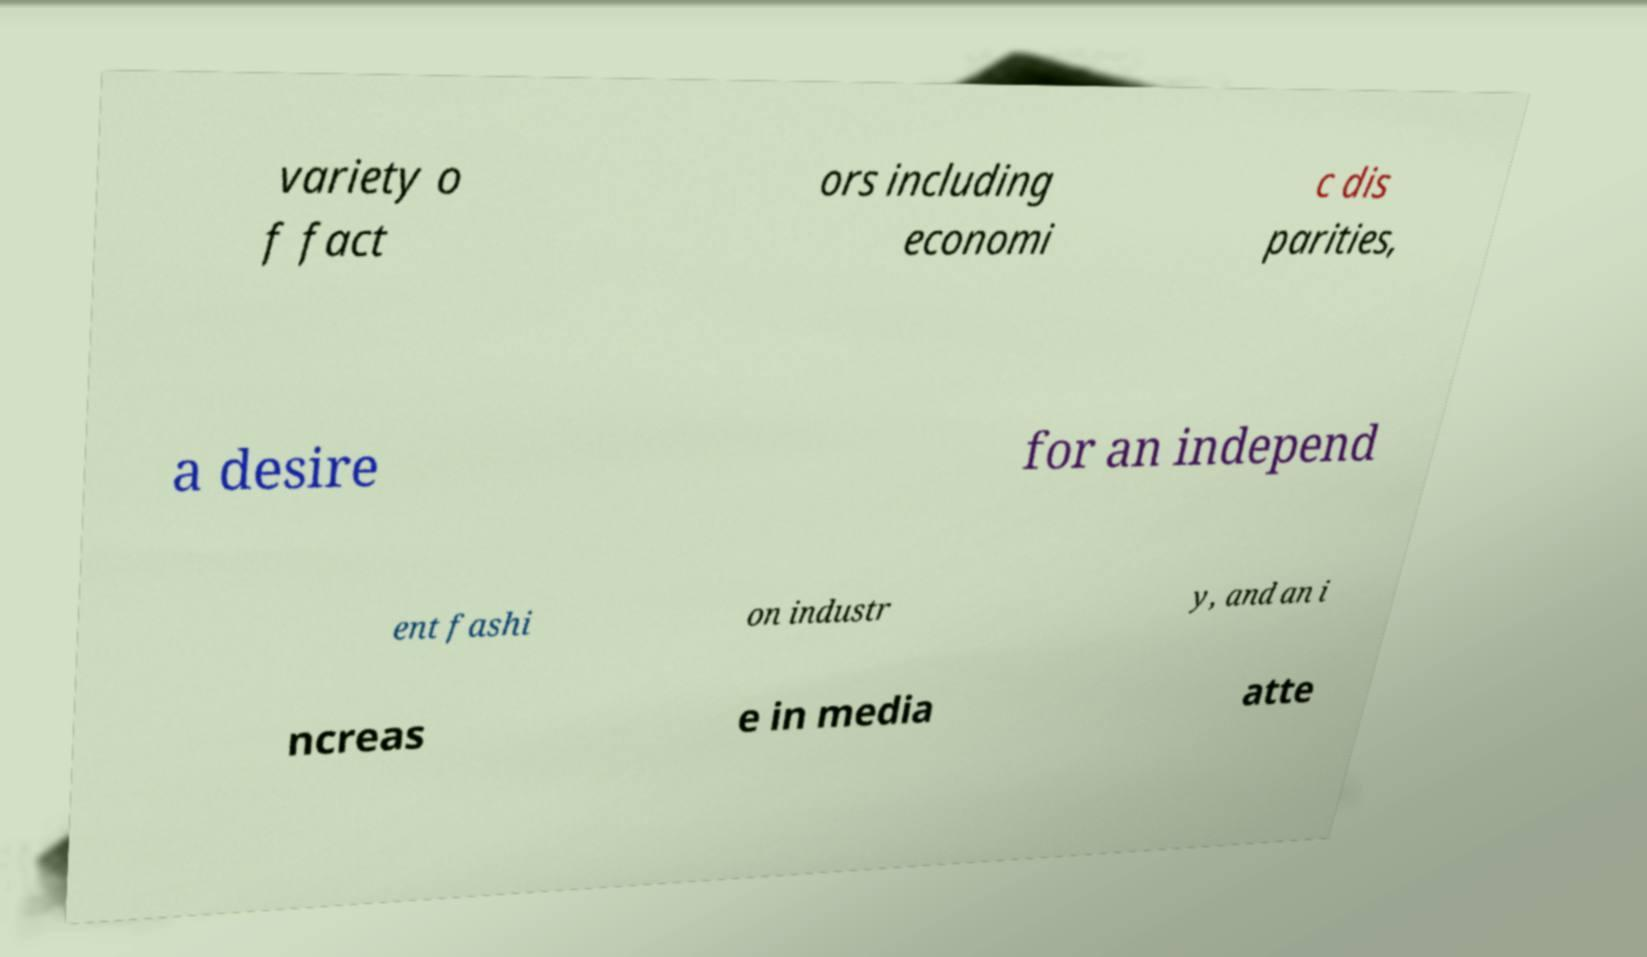Please identify and transcribe the text found in this image. variety o f fact ors including economi c dis parities, a desire for an independ ent fashi on industr y, and an i ncreas e in media atte 